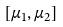Convert formula to latex. <formula><loc_0><loc_0><loc_500><loc_500>[ \mu _ { 1 } , \mu _ { 2 } ]</formula> 